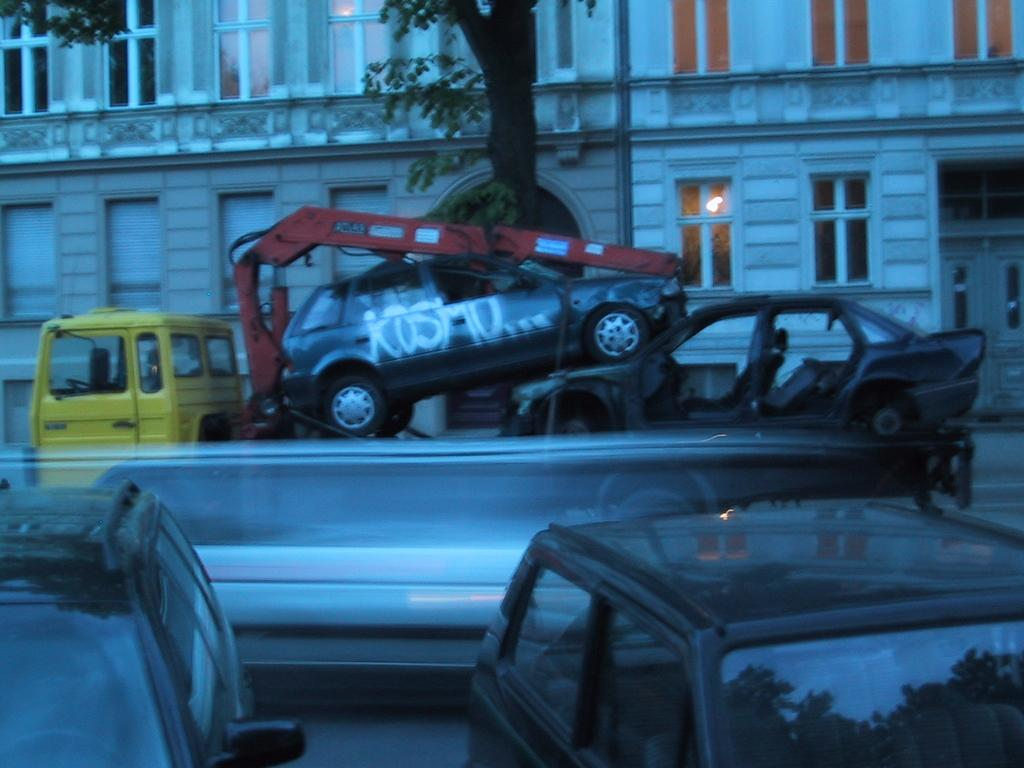What type of structures can be seen in the image? There are buildings in the image. What natural element is present in the image? There is a tree in the image. What construction equipment is visible in the image? There is a crane in the image. What type of vehicles can be seen in the image? There are cars in the image. What is the acoustics like in the image? The provided facts do not give any information about the acoustics in the image. How does the tree balance itself in the image? The tree does not need to balance itself in the image; it is a stationary object. 